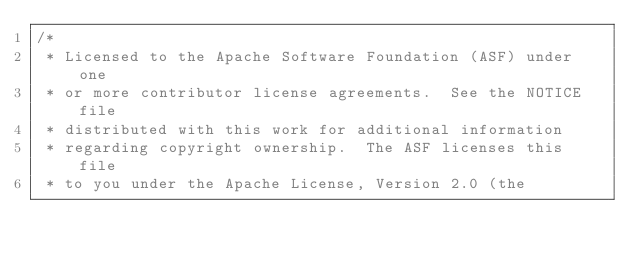<code> <loc_0><loc_0><loc_500><loc_500><_Java_>/*
 * Licensed to the Apache Software Foundation (ASF) under one
 * or more contributor license agreements.  See the NOTICE file
 * distributed with this work for additional information
 * regarding copyright ownership.  The ASF licenses this file
 * to you under the Apache License, Version 2.0 (the</code> 